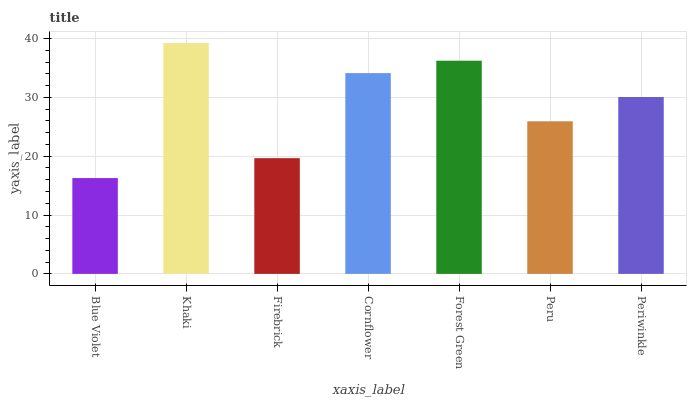Is Blue Violet the minimum?
Answer yes or no. Yes. Is Khaki the maximum?
Answer yes or no. Yes. Is Firebrick the minimum?
Answer yes or no. No. Is Firebrick the maximum?
Answer yes or no. No. Is Khaki greater than Firebrick?
Answer yes or no. Yes. Is Firebrick less than Khaki?
Answer yes or no. Yes. Is Firebrick greater than Khaki?
Answer yes or no. No. Is Khaki less than Firebrick?
Answer yes or no. No. Is Periwinkle the high median?
Answer yes or no. Yes. Is Periwinkle the low median?
Answer yes or no. Yes. Is Khaki the high median?
Answer yes or no. No. Is Firebrick the low median?
Answer yes or no. No. 